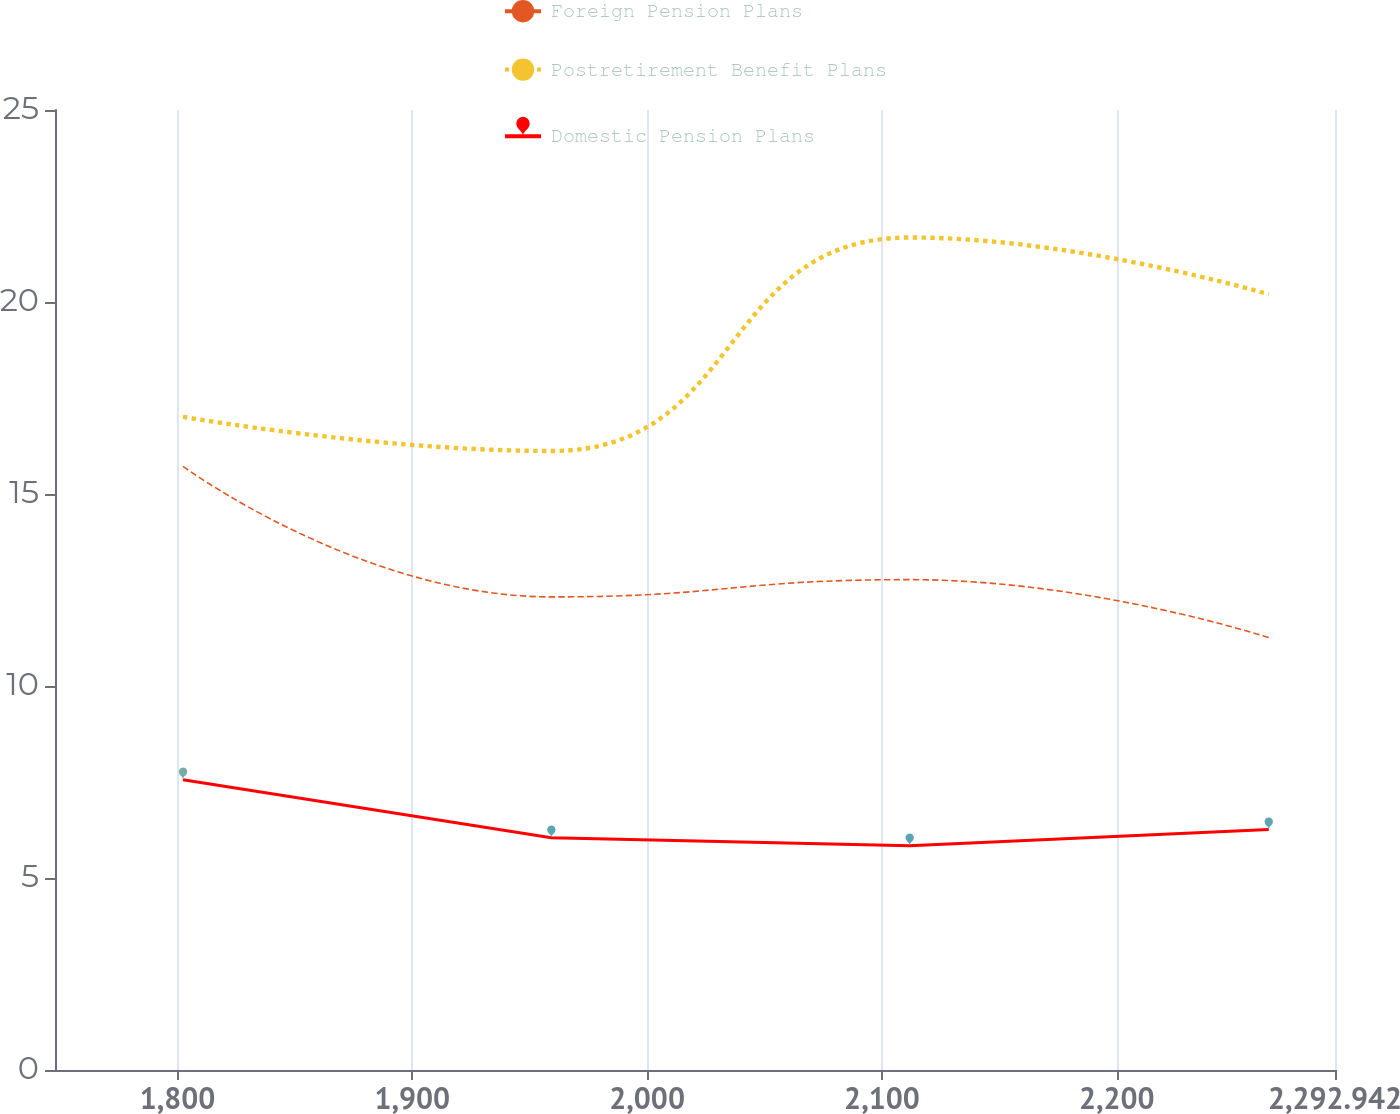Convert chart to OTSL. <chart><loc_0><loc_0><loc_500><loc_500><line_chart><ecel><fcel>Foreign Pension Plans<fcel>Postretirement Benefit Plans<fcel>Domestic Pension Plans<nl><fcel>1802.37<fcel>15.72<fcel>17.01<fcel>7.56<nl><fcel>1959.23<fcel>12.32<fcel>16.12<fcel>6.05<nl><fcel>2111.82<fcel>12.77<fcel>21.68<fcel>5.84<nl><fcel>2264.73<fcel>11.26<fcel>20.2<fcel>6.26<nl><fcel>2347.45<fcel>11.87<fcel>23.37<fcel>5.42<nl></chart> 